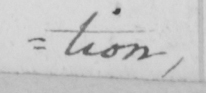Please provide the text content of this handwritten line. tion , 